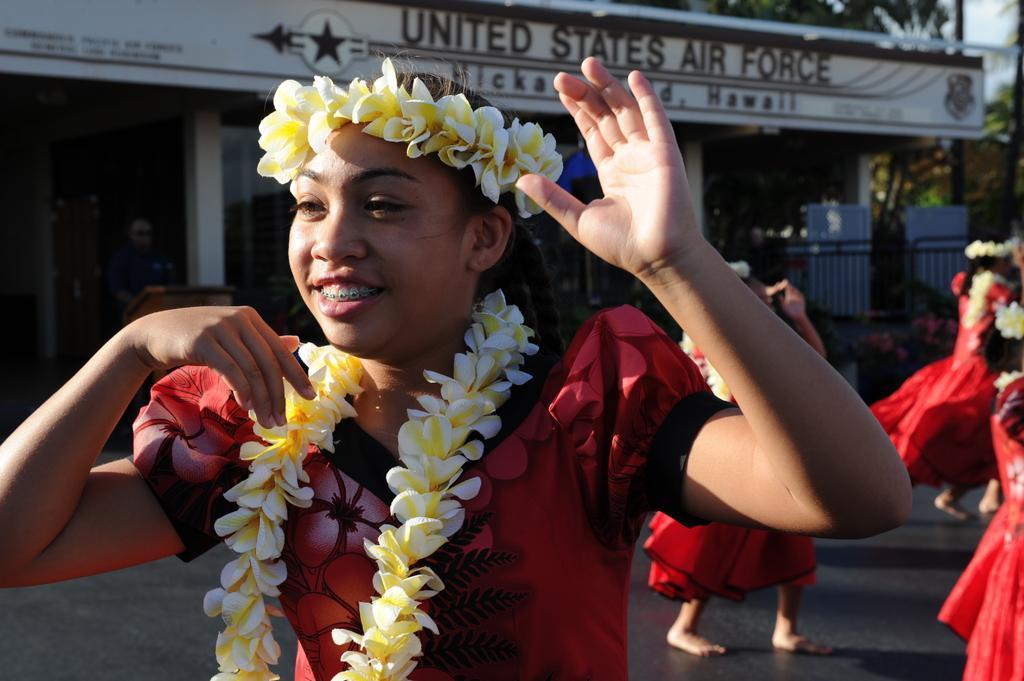Could you give a brief overview of what you see in this image? In this picture there are people wore garlands and we can see road. In the background of the image we can see building, leaves, podium, person, sky and objects. 